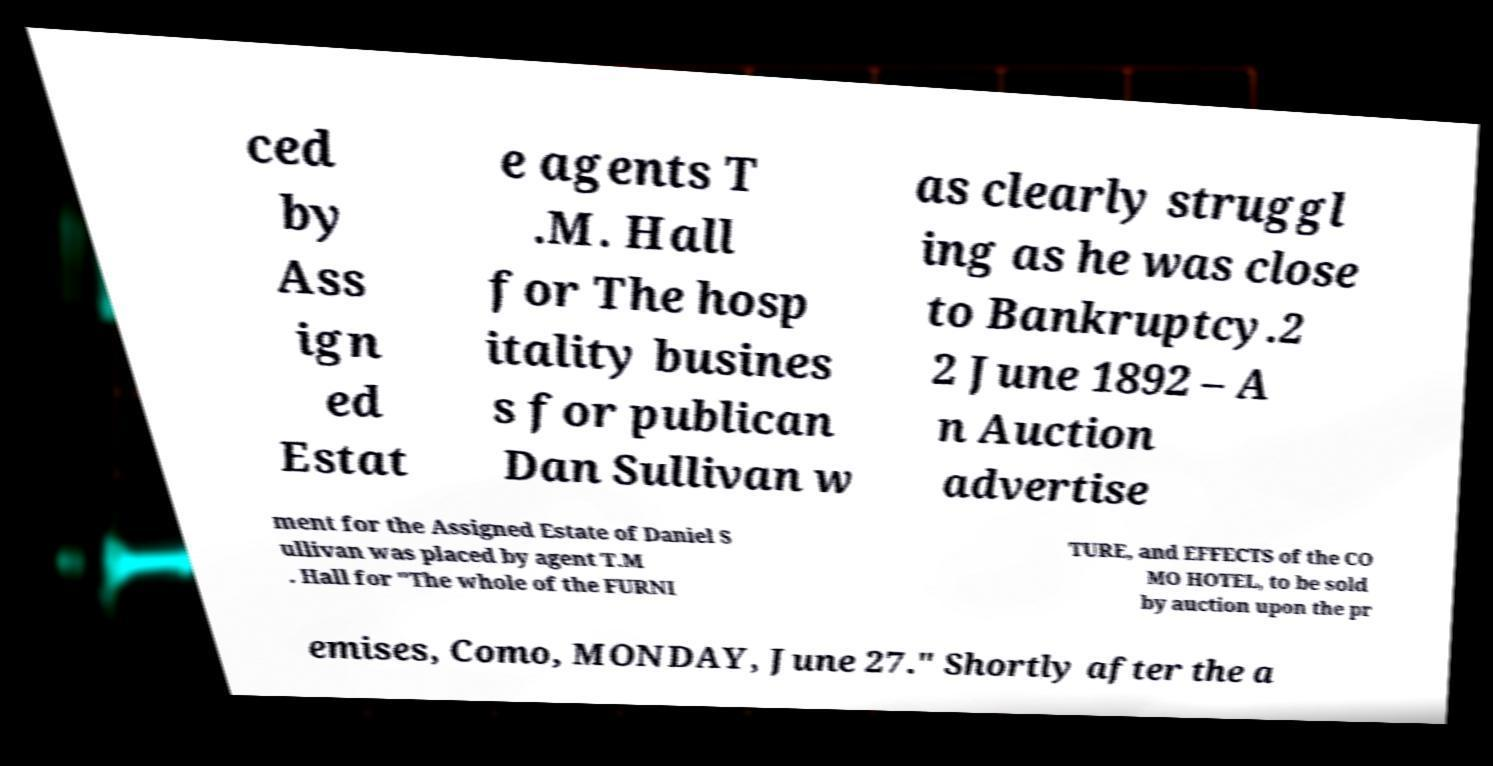Could you assist in decoding the text presented in this image and type it out clearly? ced by Ass ign ed Estat e agents T .M. Hall for The hosp itality busines s for publican Dan Sullivan w as clearly struggl ing as he was close to Bankruptcy.2 2 June 1892 – A n Auction advertise ment for the Assigned Estate of Daniel S ullivan was placed by agent T.M . Hall for "The whole of the FURNI TURE, and EFFECTS of the CO MO HOTEL, to be sold by auction upon the pr emises, Como, MONDAY, June 27." Shortly after the a 